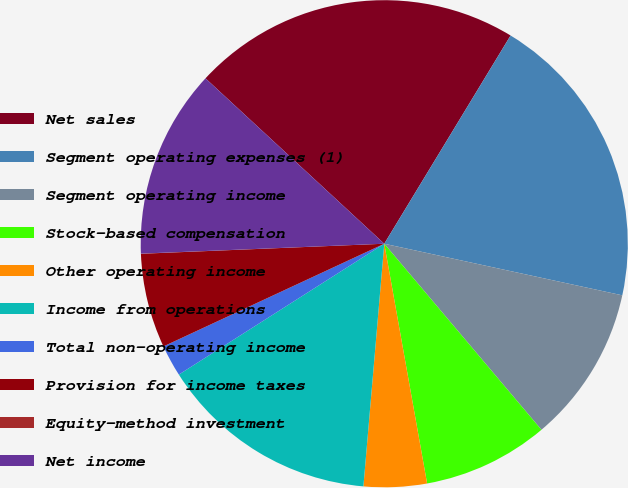Convert chart to OTSL. <chart><loc_0><loc_0><loc_500><loc_500><pie_chart><fcel>Net sales<fcel>Segment operating expenses (1)<fcel>Segment operating income<fcel>Stock-based compensation<fcel>Other operating income<fcel>Income from operations<fcel>Total non-operating income<fcel>Provision for income taxes<fcel>Equity-method investment<fcel>Net income<nl><fcel>21.8%<fcel>19.72%<fcel>10.44%<fcel>8.35%<fcel>4.18%<fcel>14.61%<fcel>2.1%<fcel>6.27%<fcel>0.01%<fcel>12.53%<nl></chart> 